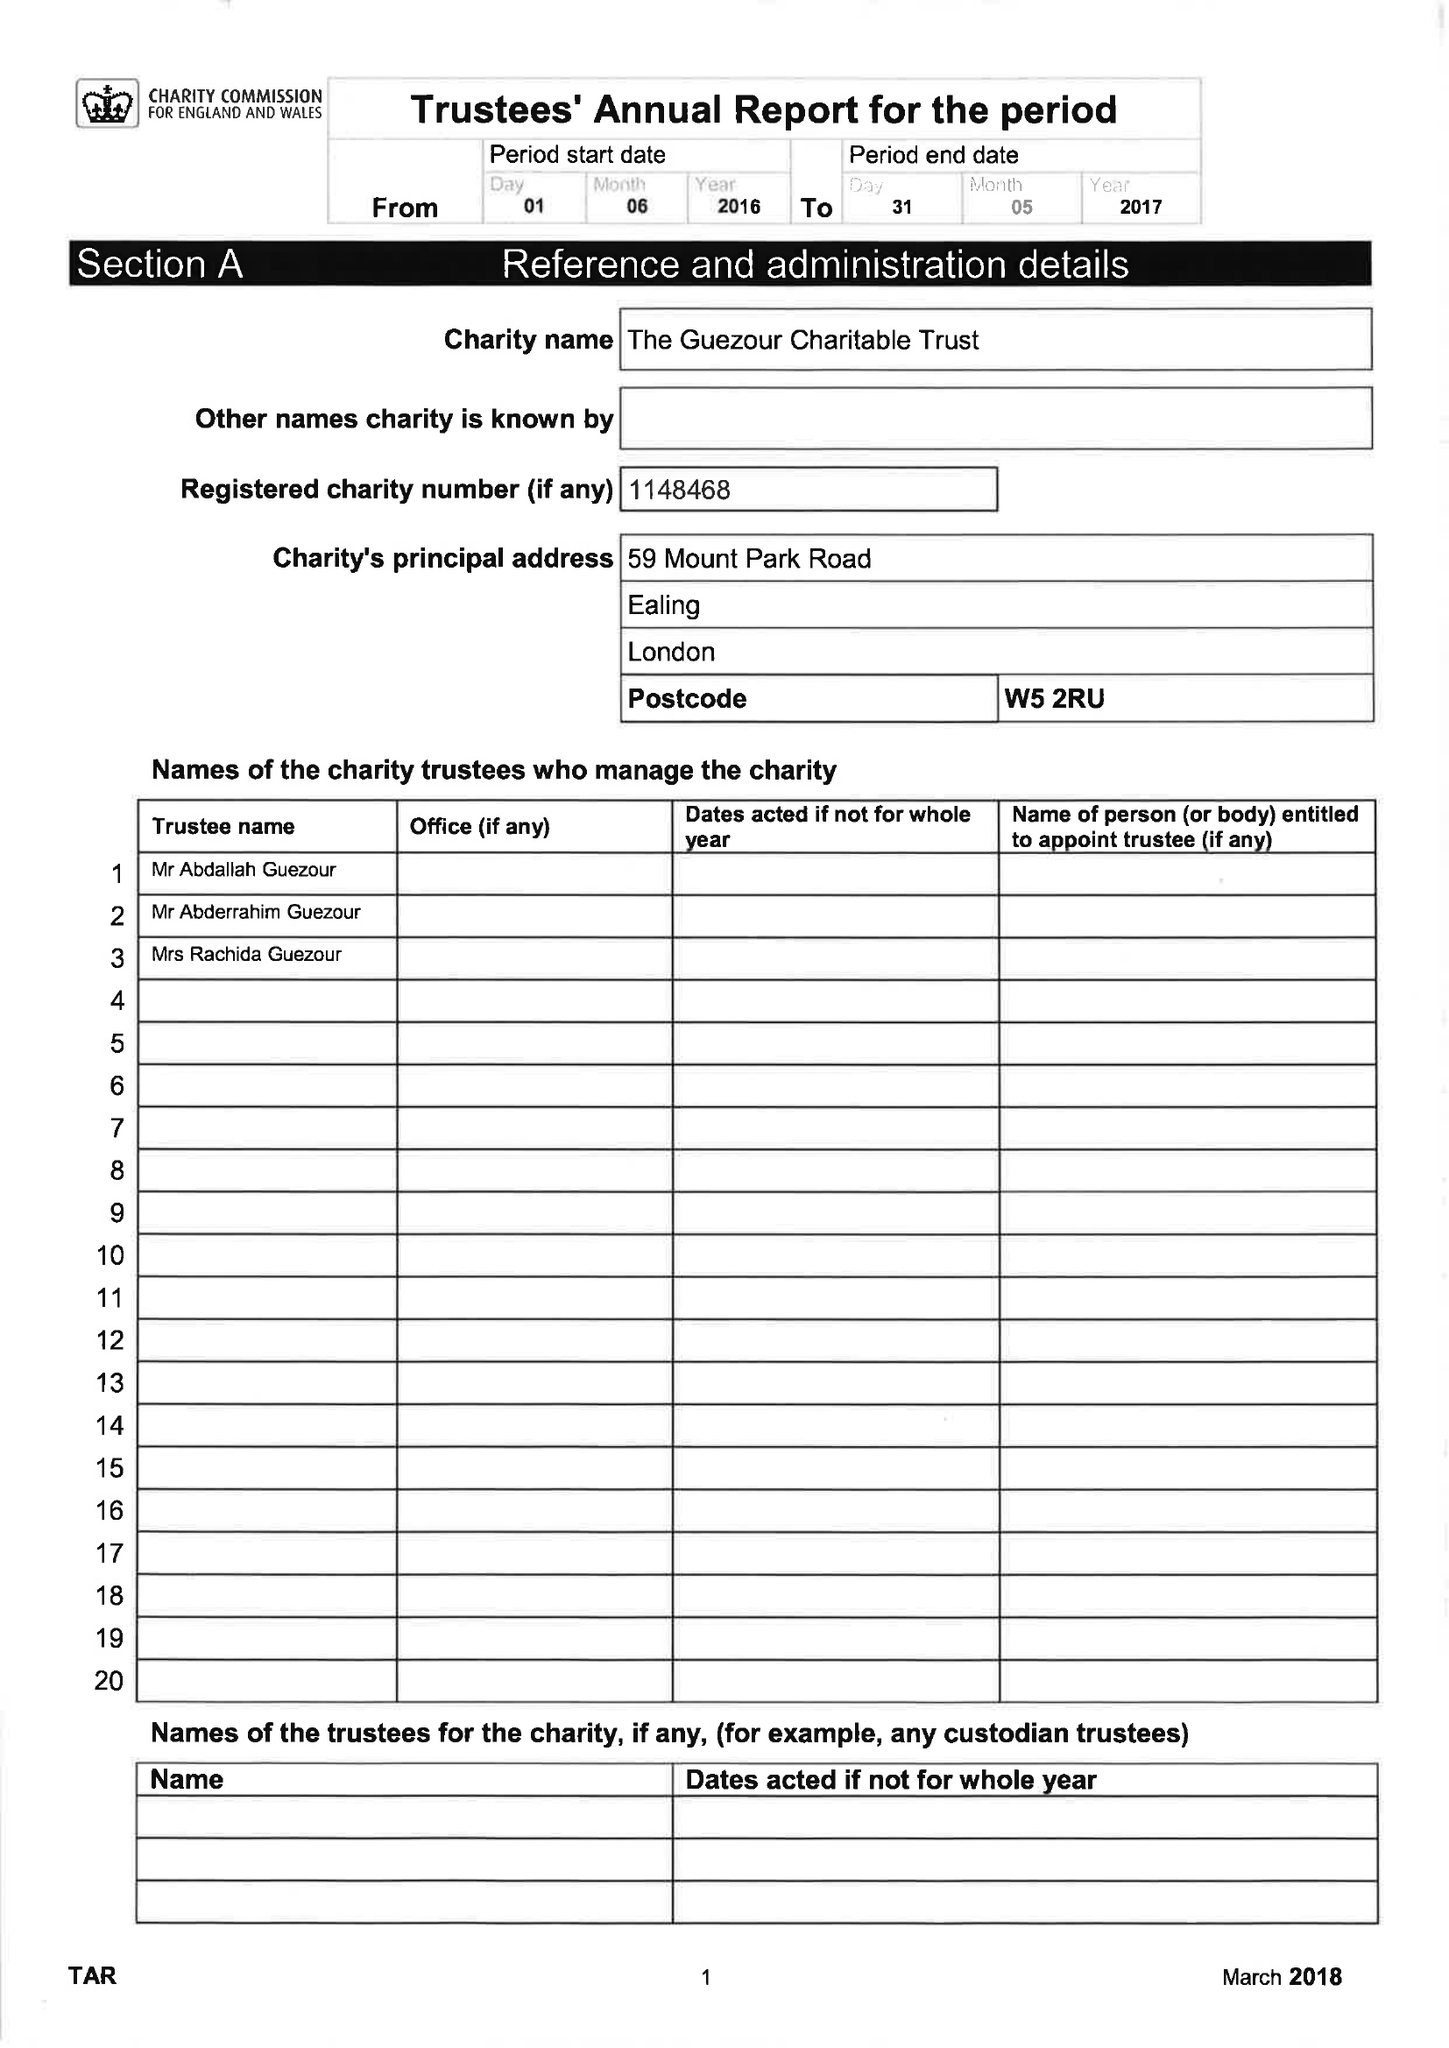What is the value for the address__street_line?
Answer the question using a single word or phrase. 59 MOUNT PARK ROAD 